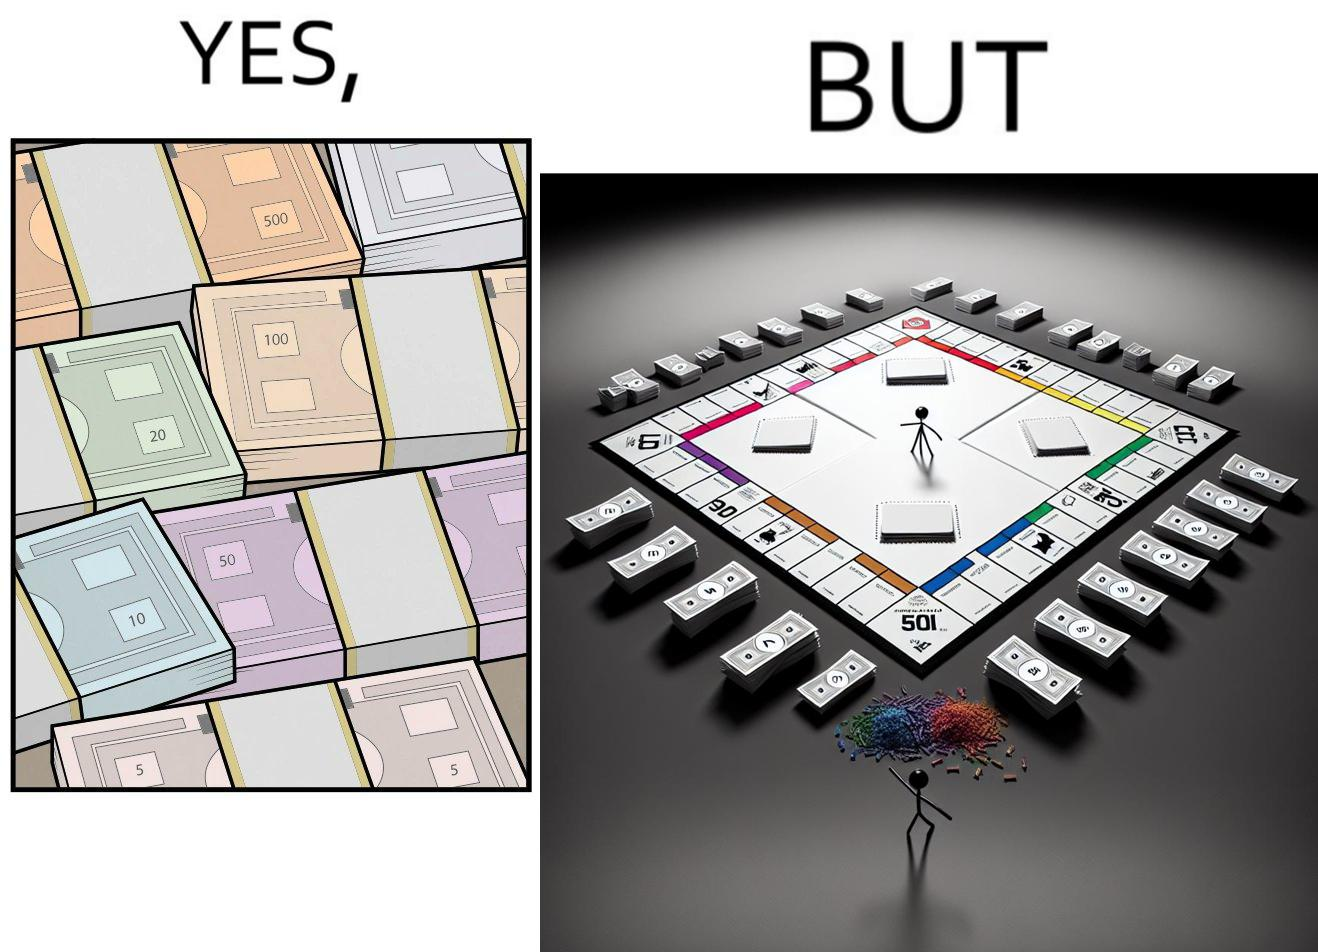Is this a satirical image? Yes, this image is satirical. 